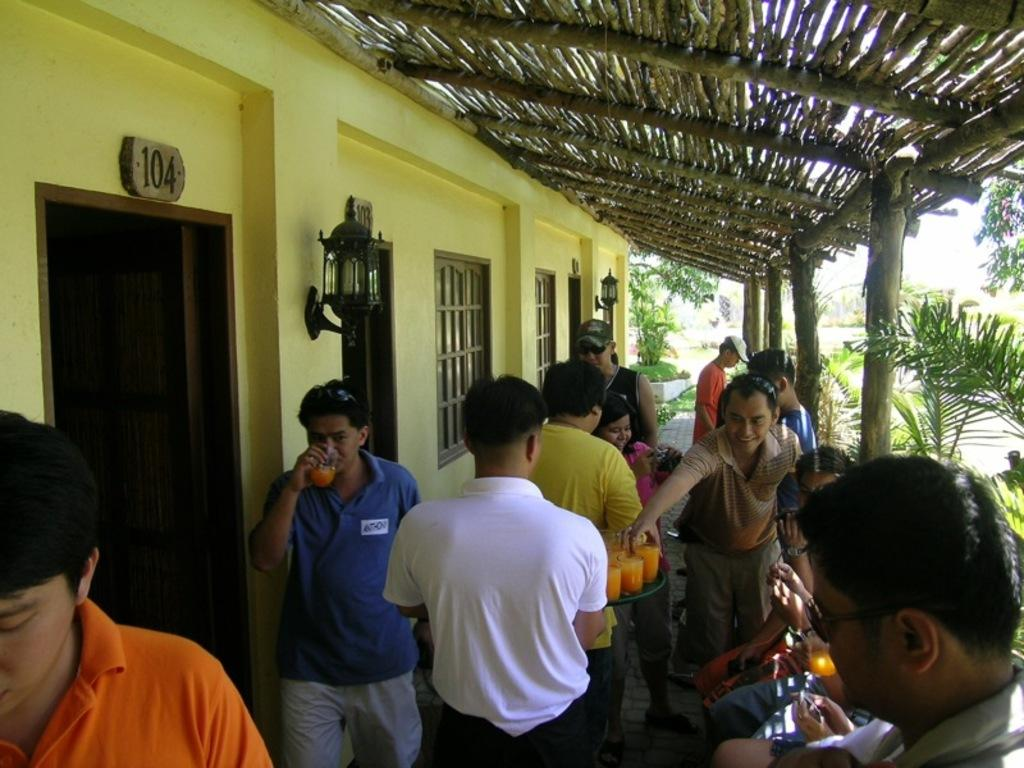Where are the people located in the image? There are people under a roof in the image. What are the people holding in their hands? The people are holding glasses in the image. What type of structure is visible in the image? There is a wall with windows and doors in the image. What type of vegetation can be seen in the image? There are trees and plants in the image. What type of locket can be seen hanging from the trees in the image? There is no locket present in the image; it only features people, a roof, glasses, a wall with windows and doors, trees, and plants. 